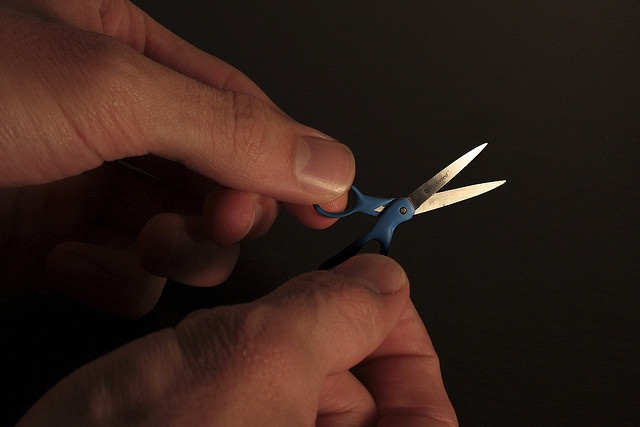Describe the objects in this image and their specific colors. I can see people in black, maroon, and brown tones and scissors in black, tan, beige, and navy tones in this image. 